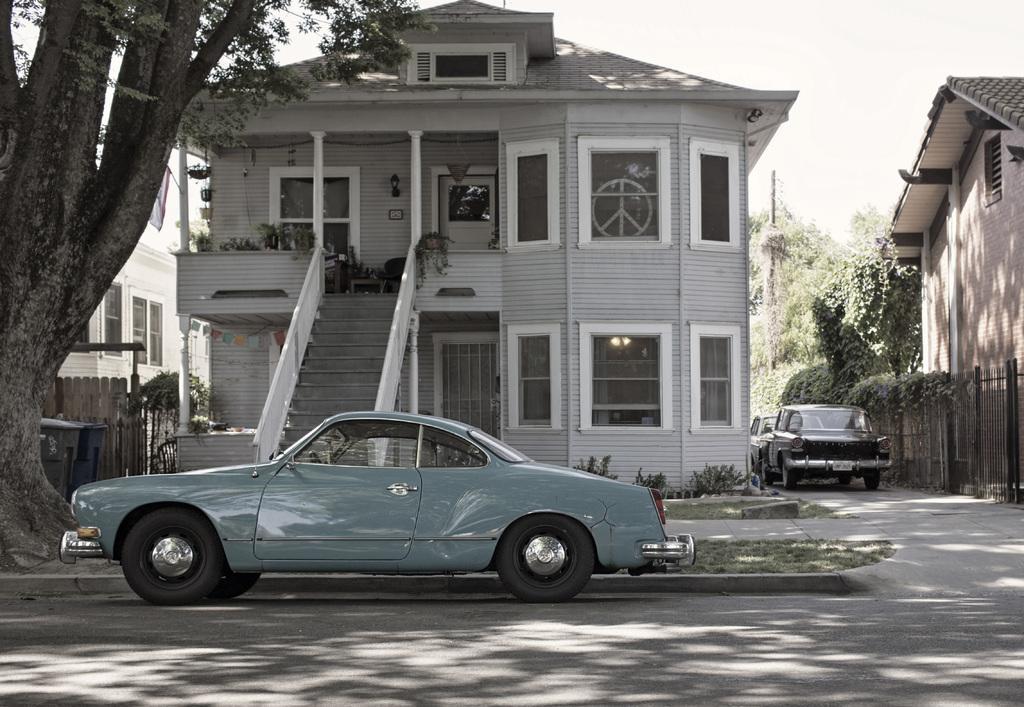Can you describe this image briefly? This picture shows few cars and we see buildings and trees and a cloudy Sky. 